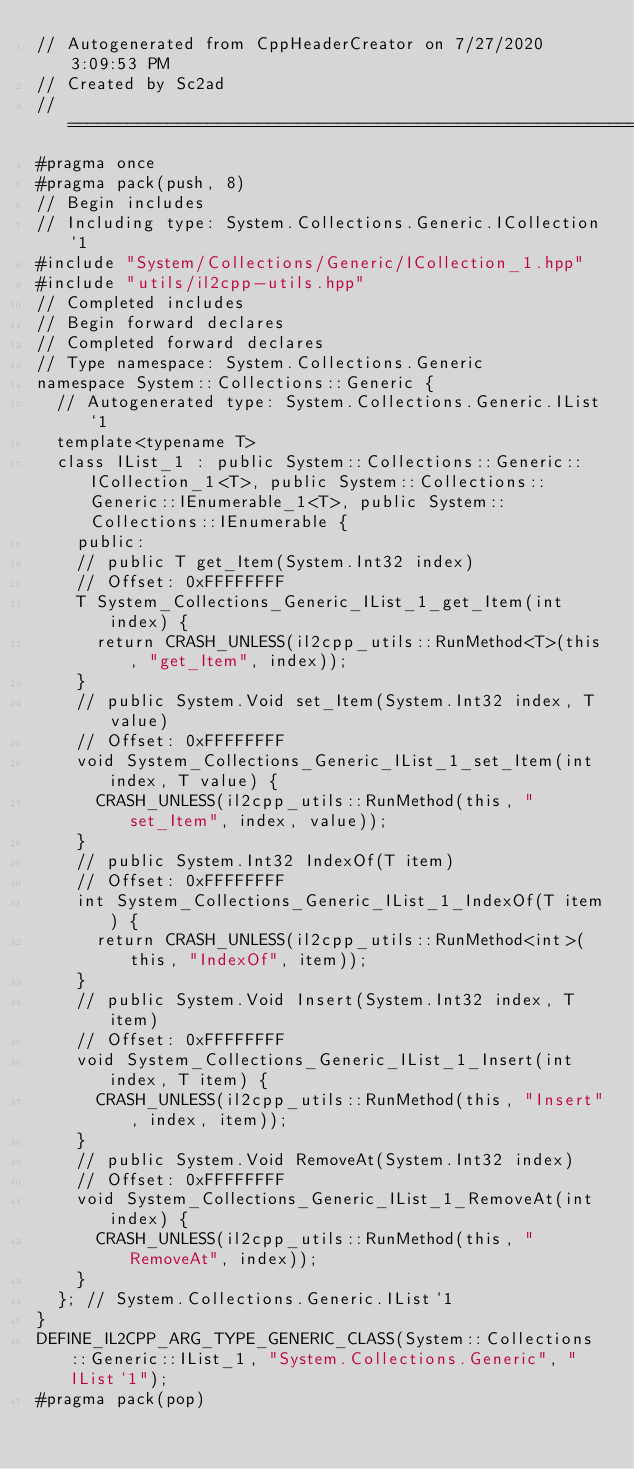Convert code to text. <code><loc_0><loc_0><loc_500><loc_500><_C++_>// Autogenerated from CppHeaderCreator on 7/27/2020 3:09:53 PM
// Created by Sc2ad
// =========================================================================
#pragma once
#pragma pack(push, 8)
// Begin includes
// Including type: System.Collections.Generic.ICollection`1
#include "System/Collections/Generic/ICollection_1.hpp"
#include "utils/il2cpp-utils.hpp"
// Completed includes
// Begin forward declares
// Completed forward declares
// Type namespace: System.Collections.Generic
namespace System::Collections::Generic {
  // Autogenerated type: System.Collections.Generic.IList`1
  template<typename T>
  class IList_1 : public System::Collections::Generic::ICollection_1<T>, public System::Collections::Generic::IEnumerable_1<T>, public System::Collections::IEnumerable {
    public:
    // public T get_Item(System.Int32 index)
    // Offset: 0xFFFFFFFF
    T System_Collections_Generic_IList_1_get_Item(int index) {
      return CRASH_UNLESS(il2cpp_utils::RunMethod<T>(this, "get_Item", index));
    }
    // public System.Void set_Item(System.Int32 index, T value)
    // Offset: 0xFFFFFFFF
    void System_Collections_Generic_IList_1_set_Item(int index, T value) {
      CRASH_UNLESS(il2cpp_utils::RunMethod(this, "set_Item", index, value));
    }
    // public System.Int32 IndexOf(T item)
    // Offset: 0xFFFFFFFF
    int System_Collections_Generic_IList_1_IndexOf(T item) {
      return CRASH_UNLESS(il2cpp_utils::RunMethod<int>(this, "IndexOf", item));
    }
    // public System.Void Insert(System.Int32 index, T item)
    // Offset: 0xFFFFFFFF
    void System_Collections_Generic_IList_1_Insert(int index, T item) {
      CRASH_UNLESS(il2cpp_utils::RunMethod(this, "Insert", index, item));
    }
    // public System.Void RemoveAt(System.Int32 index)
    // Offset: 0xFFFFFFFF
    void System_Collections_Generic_IList_1_RemoveAt(int index) {
      CRASH_UNLESS(il2cpp_utils::RunMethod(this, "RemoveAt", index));
    }
  }; // System.Collections.Generic.IList`1
}
DEFINE_IL2CPP_ARG_TYPE_GENERIC_CLASS(System::Collections::Generic::IList_1, "System.Collections.Generic", "IList`1");
#pragma pack(pop)
</code> 